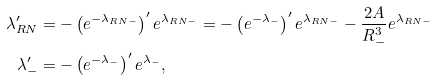<formula> <loc_0><loc_0><loc_500><loc_500>\lambda _ { R N } ^ { \prime } & = - \left ( e ^ { - \lambda _ { R N - } } \right ) ^ { \prime } e ^ { \lambda _ { R N - } } = - \left ( e ^ { - \lambda _ { - } } \right ) ^ { \prime } e ^ { \lambda _ { R N - } } - \frac { 2 A } { R _ { - } ^ { 3 } } e ^ { \lambda _ { R N - } } \\ \lambda _ { - } ^ { \prime } & = - \left ( e ^ { - \lambda _ { - } } \right ) ^ { \prime } e ^ { \lambda _ { - } } ,</formula> 